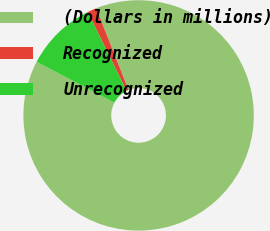Convert chart to OTSL. <chart><loc_0><loc_0><loc_500><loc_500><pie_chart><fcel>(Dollars in millions)<fcel>Recognized<fcel>Unrecognized<nl><fcel>88.71%<fcel>1.28%<fcel>10.02%<nl></chart> 